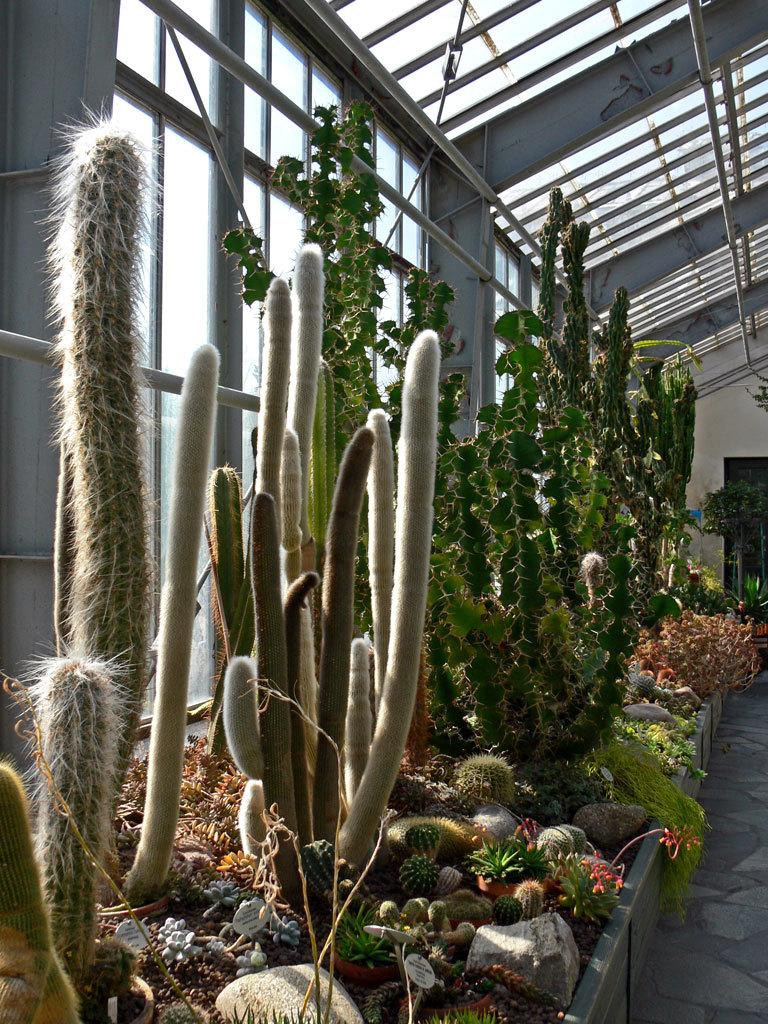What type of living organisms can be seen in the image? Plants can be seen in the image. What type of natural elements are present in the image? Rocks are present in the image. What part of the image shows the floor? The bottom right side of the image shows the floor. What type of windows are visible in the image? Glass windows are visible in the image. What type of architectural feature can be seen in the image? Iron grilles are present in the image. What type of joke is being told by the plants in the image? There is no joke being told by the plants in the image, as plants do not have the ability to tell jokes. 